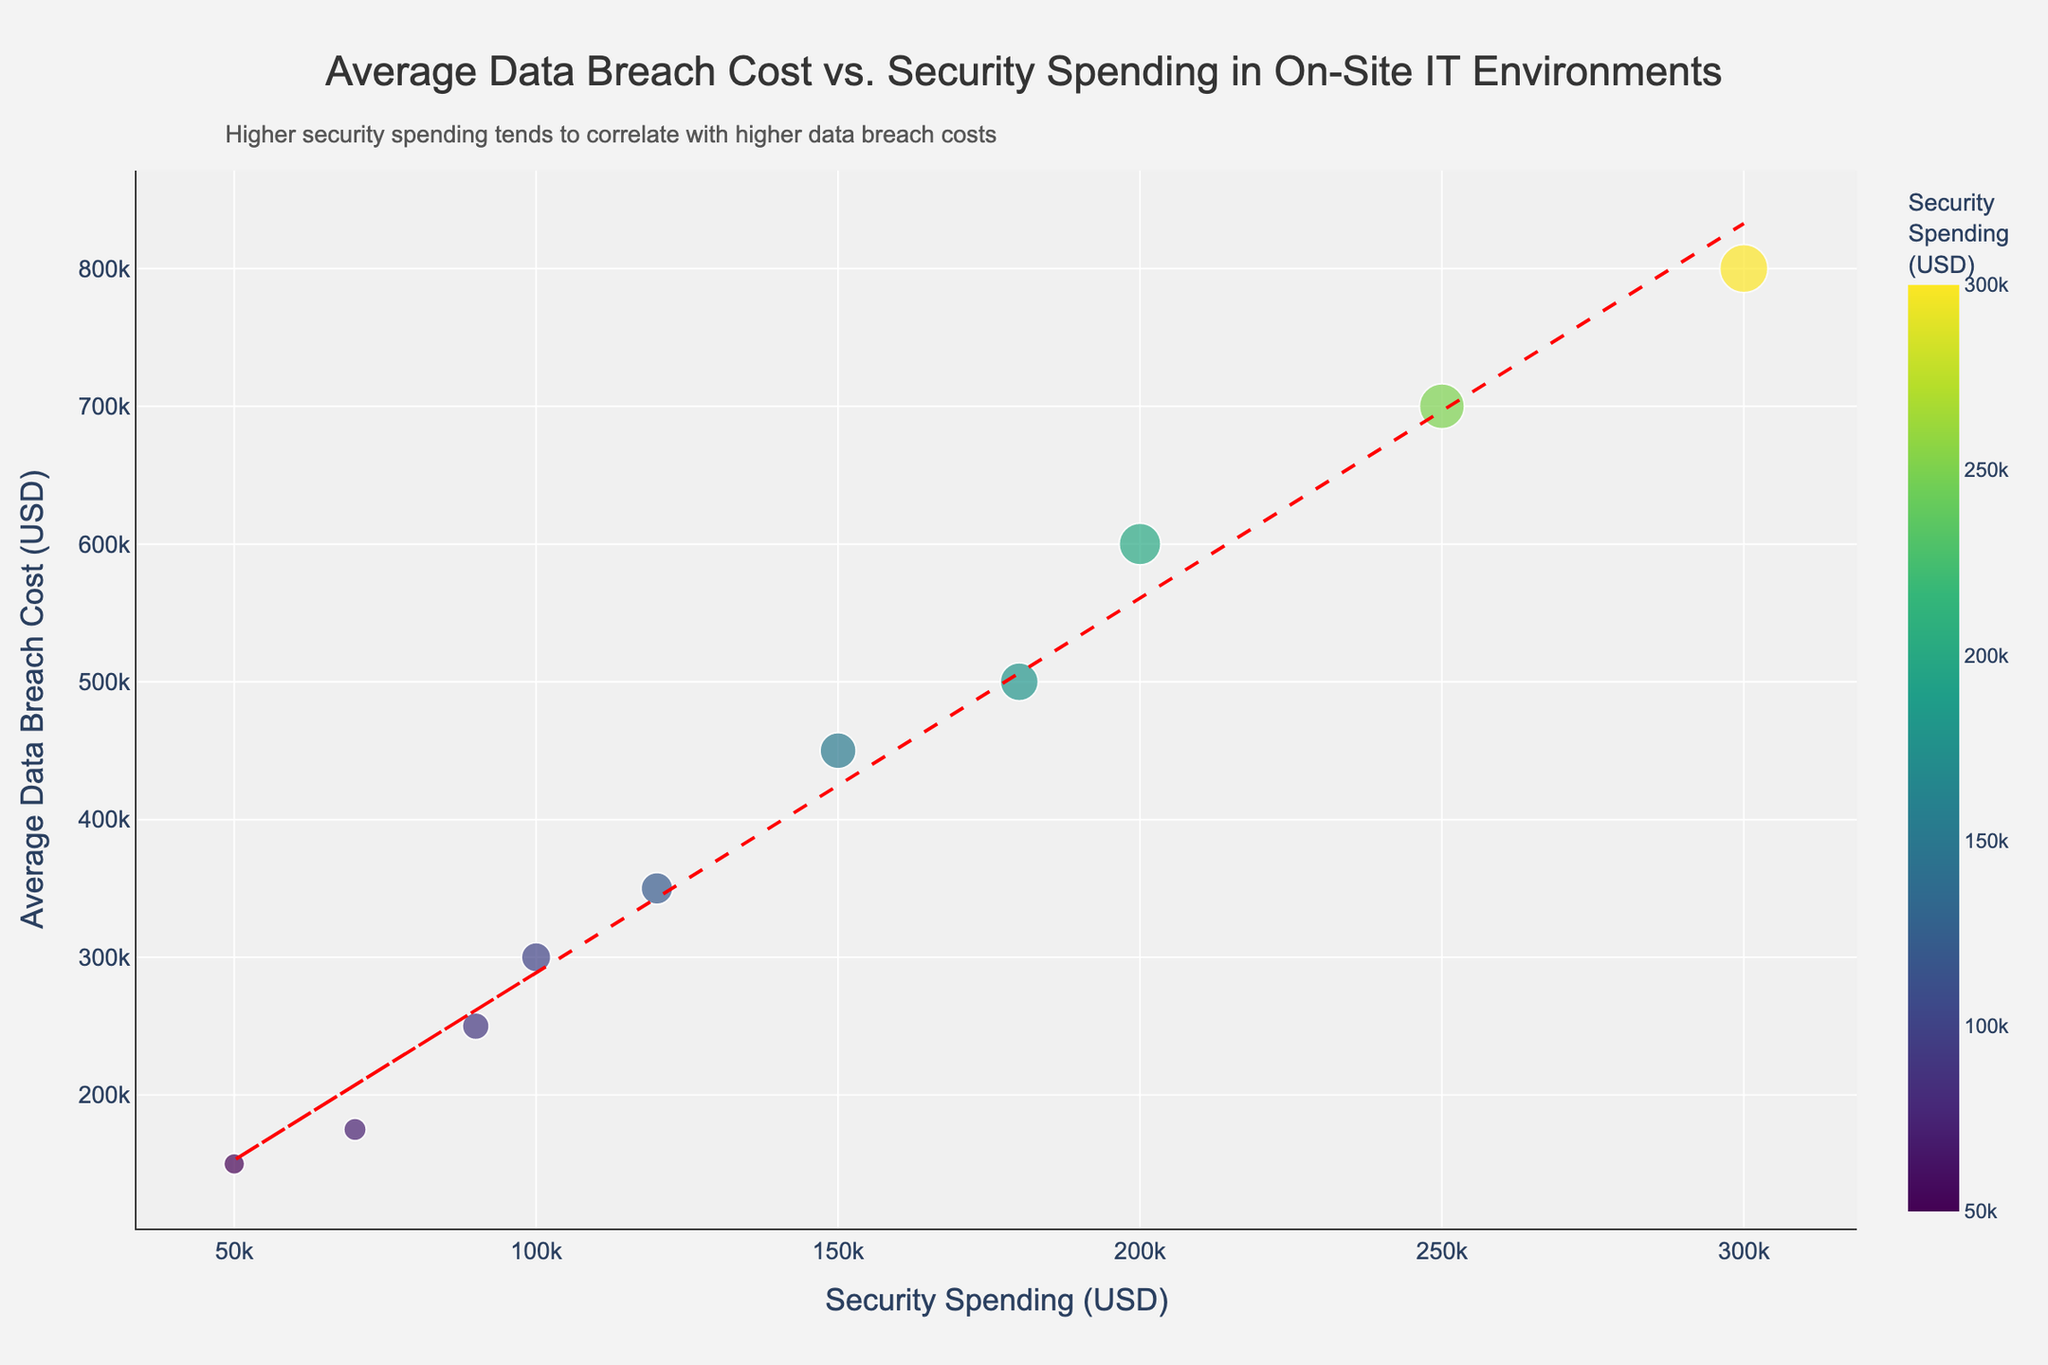What is the title of the scatter plot? The title is displayed at the top of the scatter plot in a bold, larger font size. By reading this text, we can determine the title.
Answer: Average Data Breach Cost vs. Security Spending in On-Site IT Environments How many companies are plotted in the scatter plot? Each company corresponds to a data point on the scatter plot. Counting all the markers (or points) on the plot gives the number of companies.
Answer: 10 Which company has the highest security spending? The x-axis represents security spending. The farthest point to the right represents the company with the highest security spending. Hovering over the point shows the company's name.
Answer: Company J What is the highest average data breach cost shown in the plot? The y-axis represents the average data breach cost. The highest point along the y-axis indicates the highest value. Hovering over this point reveals the cost.
Answer: 800000 Does higher security spending always result in lower average data breach costs? Observing the trend line and the scatter plot arrangement, we assess the relationship between security spending and average data breach costs. Higher points should be examined to determine correlation.
Answer: No Which company has the highest average data breach cost compared to its security spending? By examining the ratio of average data breach cost to security spending for each company, we can identify the one with the highest value. This can be inferred from the plot if a point is significantly higher for its corresponding x-value.
Answer: Company J What is the trend shown by the added trend line in the plot? The trend line, often represented by a dashed line, shows the overall direction or relationship between the variables on the x and y axes. By looking at the slope of the line, the trend can be inferred.
Answer: Positive correlation Which company has the lowest average data breach cost, and how much did they spend on security? The lowest point along the y-axis marks the lowest average data breach cost. Hovering over this point reveals the company and its corresponding x (security spending) value.
Answer: Company H, 50000 